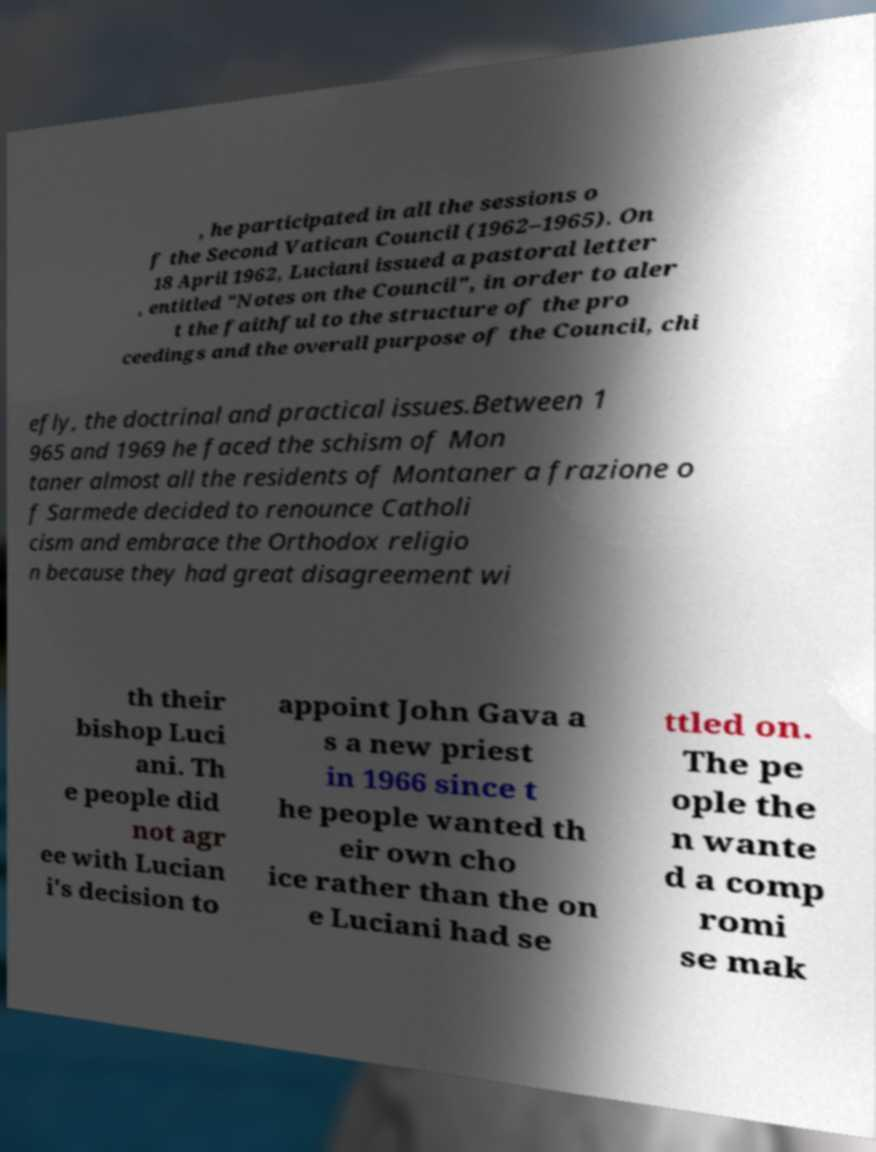Can you read and provide the text displayed in the image?This photo seems to have some interesting text. Can you extract and type it out for me? , he participated in all the sessions o f the Second Vatican Council (1962–1965). On 18 April 1962, Luciani issued a pastoral letter , entitled "Notes on the Council", in order to aler t the faithful to the structure of the pro ceedings and the overall purpose of the Council, chi efly, the doctrinal and practical issues.Between 1 965 and 1969 he faced the schism of Mon taner almost all the residents of Montaner a frazione o f Sarmede decided to renounce Catholi cism and embrace the Orthodox religio n because they had great disagreement wi th their bishop Luci ani. Th e people did not agr ee with Lucian i's decision to appoint John Gava a s a new priest in 1966 since t he people wanted th eir own cho ice rather than the on e Luciani had se ttled on. The pe ople the n wante d a comp romi se mak 